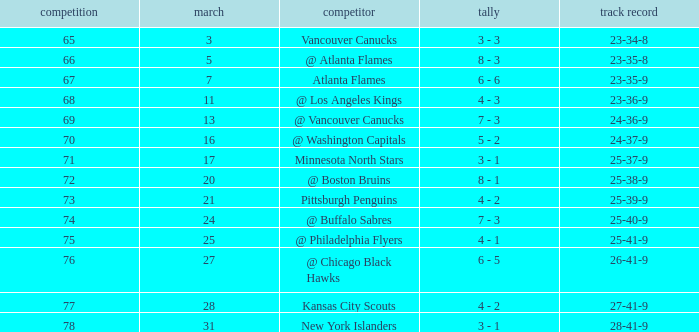What was the score when they had a 25-41-9 record? 4 - 1. Would you mind parsing the complete table? {'header': ['competition', 'march', 'competitor', 'tally', 'track record'], 'rows': [['65', '3', 'Vancouver Canucks', '3 - 3', '23-34-8'], ['66', '5', '@ Atlanta Flames', '8 - 3', '23-35-8'], ['67', '7', 'Atlanta Flames', '6 - 6', '23-35-9'], ['68', '11', '@ Los Angeles Kings', '4 - 3', '23-36-9'], ['69', '13', '@ Vancouver Canucks', '7 - 3', '24-36-9'], ['70', '16', '@ Washington Capitals', '5 - 2', '24-37-9'], ['71', '17', 'Minnesota North Stars', '3 - 1', '25-37-9'], ['72', '20', '@ Boston Bruins', '8 - 1', '25-38-9'], ['73', '21', 'Pittsburgh Penguins', '4 - 2', '25-39-9'], ['74', '24', '@ Buffalo Sabres', '7 - 3', '25-40-9'], ['75', '25', '@ Philadelphia Flyers', '4 - 1', '25-41-9'], ['76', '27', '@ Chicago Black Hawks', '6 - 5', '26-41-9'], ['77', '28', 'Kansas City Scouts', '4 - 2', '27-41-9'], ['78', '31', 'New York Islanders', '3 - 1', '28-41-9']]} 